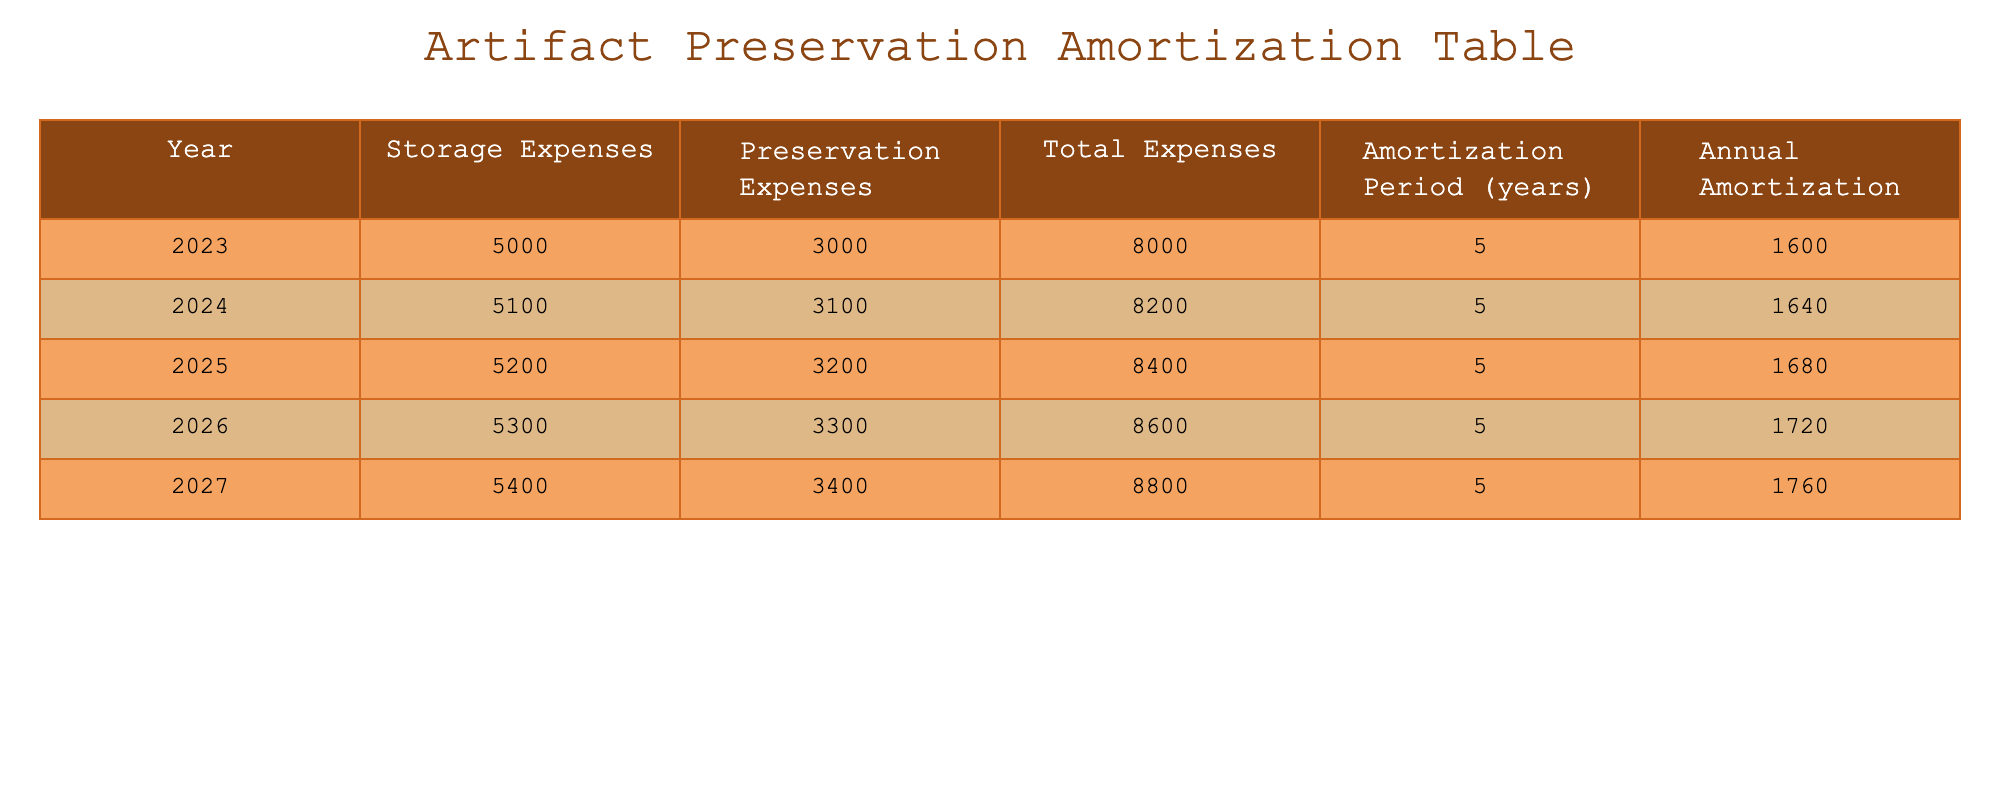What were the total expenses for 2025? By looking at the row for the year 2025 in the table, we see that the Total Expenses column has the value 8400.
Answer: 8400 What is the annual amortization for the year 2024? In the table, the row for the year 2024 shows that the Annual Amortization value is 1640.
Answer: 1640 Did the storage expenses increase every year? By examining the Storage Expenses column, we can observe that each year's value is greater than the previous year's value, confirming that there is a consistent increase.
Answer: Yes What is the sum of preservation expenses for all years combined? We need to add the Preservation Expenses for each year: 3000 + 3100 + 3200 + 3300 + 3400 = 16000.
Answer: 16000 What is the average total expenses over the five years? To find the average, we sum the Total Expenses for each year: 8000 + 8200 + 8400 + 8600 + 8800 = 41000, and then divide by 5, giving us 41000/5 = 8200.
Answer: 8200 In 2026, what is the difference between storage and preservation expenses? For 2026, the Storage Expenses are 5300 and Preservation Expenses are 3300. Calculating the difference gives us 5300 - 3300 = 2000.
Answer: 2000 What is the total annual amortization across all five years? We add the Annual Amortization for each year: 1600 + 1640 + 1680 + 1720 + 1760 = 8400.
Answer: 8400 Is the annual amortization increasing steadily? If we compare the Annual Amortization values across the years, we see that each year's value is higher than the prior one, confirming a steady increase.
Answer: Yes What was the highest total expense during the five years? By comparing the Total Expenses values from all years, we find that the highest value is 8800 in the year 2027.
Answer: 8800 